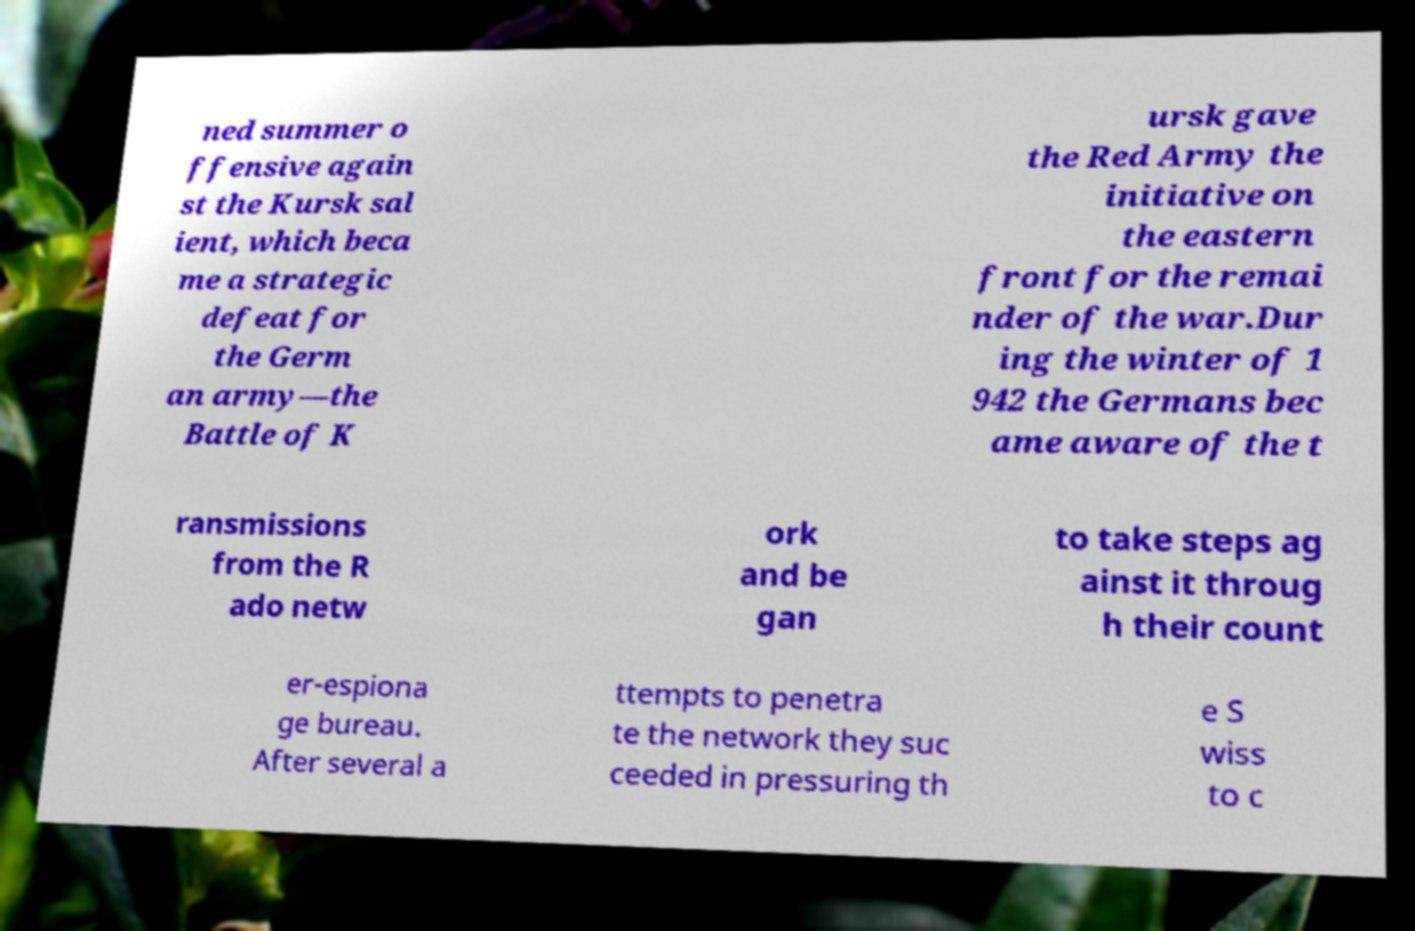Please read and relay the text visible in this image. What does it say? ned summer o ffensive again st the Kursk sal ient, which beca me a strategic defeat for the Germ an army—the Battle of K ursk gave the Red Army the initiative on the eastern front for the remai nder of the war.Dur ing the winter of 1 942 the Germans bec ame aware of the t ransmissions from the R ado netw ork and be gan to take steps ag ainst it throug h their count er-espiona ge bureau. After several a ttempts to penetra te the network they suc ceeded in pressuring th e S wiss to c 